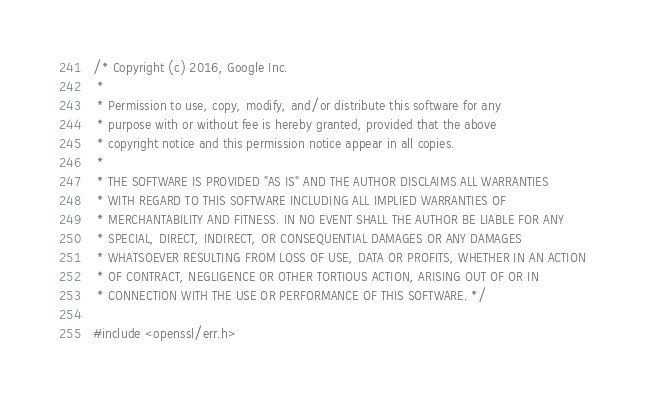Convert code to text. <code><loc_0><loc_0><loc_500><loc_500><_C++_>/* Copyright (c) 2016, Google Inc.
 *
 * Permission to use, copy, modify, and/or distribute this software for any
 * purpose with or without fee is hereby granted, provided that the above
 * copyright notice and this permission notice appear in all copies.
 *
 * THE SOFTWARE IS PROVIDED "AS IS" AND THE AUTHOR DISCLAIMS ALL WARRANTIES
 * WITH REGARD TO THIS SOFTWARE INCLUDING ALL IMPLIED WARRANTIES OF
 * MERCHANTABILITY AND FITNESS. IN NO EVENT SHALL THE AUTHOR BE LIABLE FOR ANY
 * SPECIAL, DIRECT, INDIRECT, OR CONSEQUENTIAL DAMAGES OR ANY DAMAGES
 * WHATSOEVER RESULTING FROM LOSS OF USE, DATA OR PROFITS, WHETHER IN AN ACTION
 * OF CONTRACT, NEGLIGENCE OR OTHER TORTIOUS ACTION, ARISING OUT OF OR IN
 * CONNECTION WITH THE USE OR PERFORMANCE OF THIS SOFTWARE. */

#include <openssl/err.h></code> 